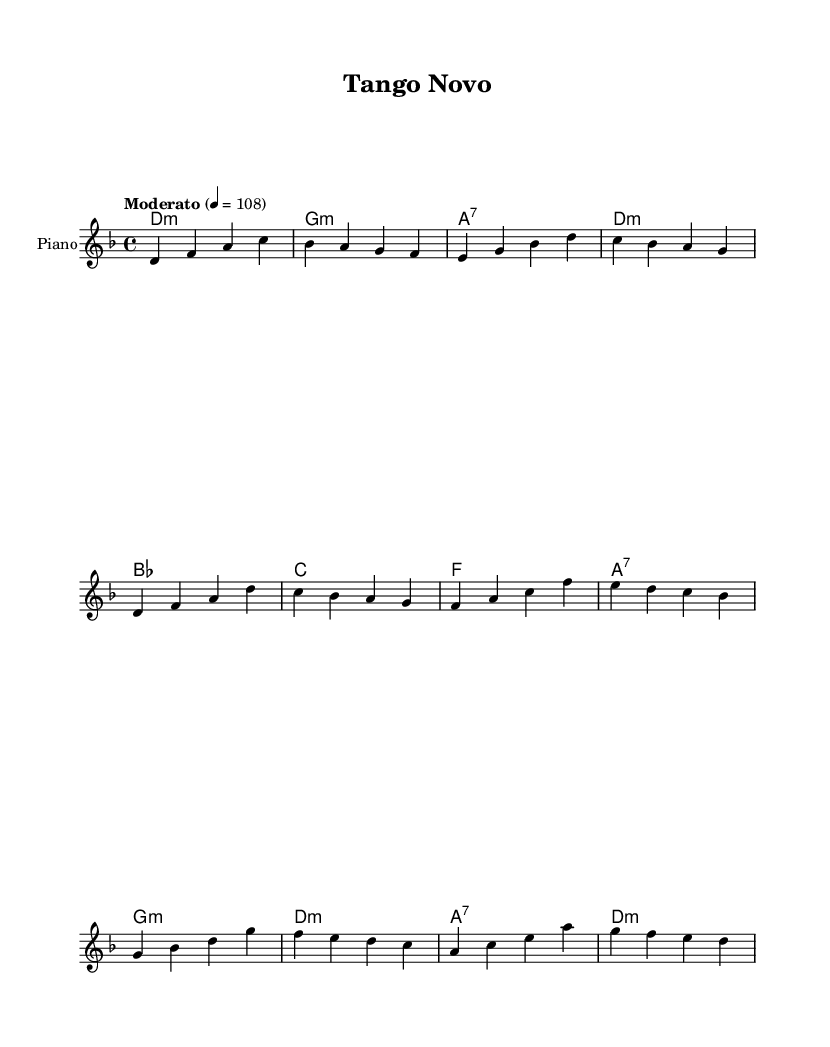What is the key signature of this music? The key signature is D minor, which contains one flat (B flat).
Answer: D minor What is the time signature of the piece? The time signature is 4/4, which indicates four beats in a measure.
Answer: 4/4 What is the tempo marking of the piece? The tempo marking is "Moderato," indicating a moderate speed, specifically marked at 108 beats per minute.
Answer: Moderato How many sections are in the music? The music consists of two sections labeled A and B, making a total of three distinct parts including the intro.
Answer: Three What is the ending chord of the A section? The A section ends on the chord D minor, as shown in the harmonies right after the melody for the A section.
Answer: D minor Which key do the harmonies start with? The harmonies begin with D minor, which is indicated as the first chord in the sequence.
Answer: D minor What is the predominant genre influence in this piece? The predominant genre influence in this piece is a fusion of Argentine tango with Brazilian bossa nova, characterized by the rhythmic and harmonic elements.
Answer: Fusion 